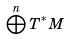<formula> <loc_0><loc_0><loc_500><loc_500>\bigoplus ^ { n } T ^ { * } M</formula> 